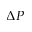<formula> <loc_0><loc_0><loc_500><loc_500>\Delta P</formula> 